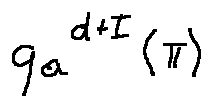Convert formula to latex. <formula><loc_0><loc_0><loc_500><loc_500>q _ { a } ^ { d + I } ( \pi )</formula> 